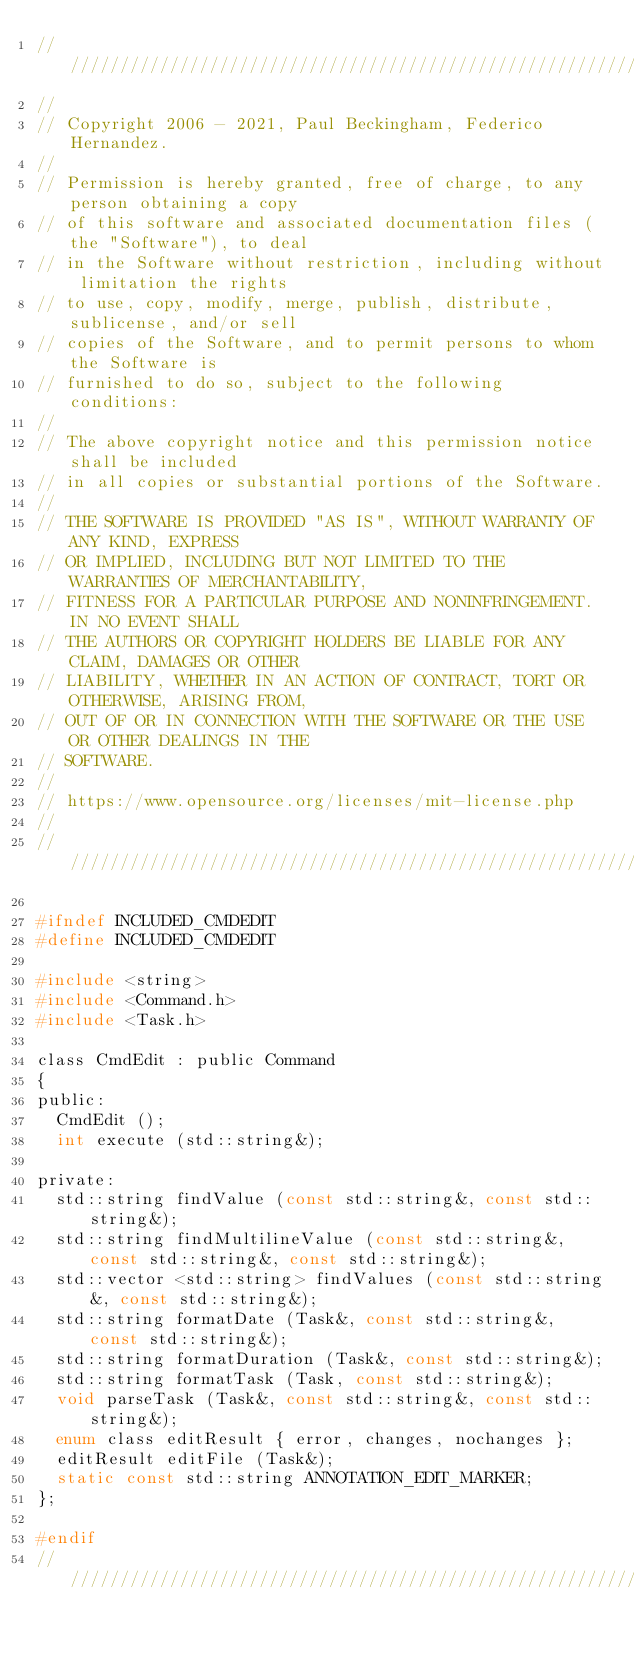<code> <loc_0><loc_0><loc_500><loc_500><_C_>////////////////////////////////////////////////////////////////////////////////
//
// Copyright 2006 - 2021, Paul Beckingham, Federico Hernandez.
//
// Permission is hereby granted, free of charge, to any person obtaining a copy
// of this software and associated documentation files (the "Software"), to deal
// in the Software without restriction, including without limitation the rights
// to use, copy, modify, merge, publish, distribute, sublicense, and/or sell
// copies of the Software, and to permit persons to whom the Software is
// furnished to do so, subject to the following conditions:
//
// The above copyright notice and this permission notice shall be included
// in all copies or substantial portions of the Software.
//
// THE SOFTWARE IS PROVIDED "AS IS", WITHOUT WARRANTY OF ANY KIND, EXPRESS
// OR IMPLIED, INCLUDING BUT NOT LIMITED TO THE WARRANTIES OF MERCHANTABILITY,
// FITNESS FOR A PARTICULAR PURPOSE AND NONINFRINGEMENT. IN NO EVENT SHALL
// THE AUTHORS OR COPYRIGHT HOLDERS BE LIABLE FOR ANY CLAIM, DAMAGES OR OTHER
// LIABILITY, WHETHER IN AN ACTION OF CONTRACT, TORT OR OTHERWISE, ARISING FROM,
// OUT OF OR IN CONNECTION WITH THE SOFTWARE OR THE USE OR OTHER DEALINGS IN THE
// SOFTWARE.
//
// https://www.opensource.org/licenses/mit-license.php
//
////////////////////////////////////////////////////////////////////////////////

#ifndef INCLUDED_CMDEDIT
#define INCLUDED_CMDEDIT

#include <string>
#include <Command.h>
#include <Task.h>

class CmdEdit : public Command
{
public:
  CmdEdit ();
  int execute (std::string&);

private:
  std::string findValue (const std::string&, const std::string&);
  std::string findMultilineValue (const std::string&, const std::string&, const std::string&);
  std::vector <std::string> findValues (const std::string&, const std::string&);
  std::string formatDate (Task&, const std::string&, const std::string&);
  std::string formatDuration (Task&, const std::string&);
  std::string formatTask (Task, const std::string&);
  void parseTask (Task&, const std::string&, const std::string&);
  enum class editResult { error, changes, nochanges };
  editResult editFile (Task&);
  static const std::string ANNOTATION_EDIT_MARKER;
};

#endif
////////////////////////////////////////////////////////////////////////////////
</code> 